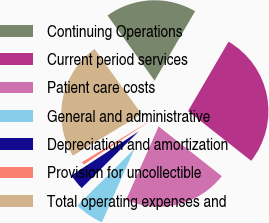Convert chart to OTSL. <chart><loc_0><loc_0><loc_500><loc_500><pie_chart><fcel>Continuing Operations<fcel>Current period services<fcel>Patient care costs<fcel>General and administrative<fcel>Depreciation and amortization<fcel>Provision for uncollectible<fcel>Total operating expenses and<nl><fcel>18.37%<fcel>27.21%<fcel>21.03%<fcel>5.9%<fcel>3.23%<fcel>0.57%<fcel>23.7%<nl></chart> 